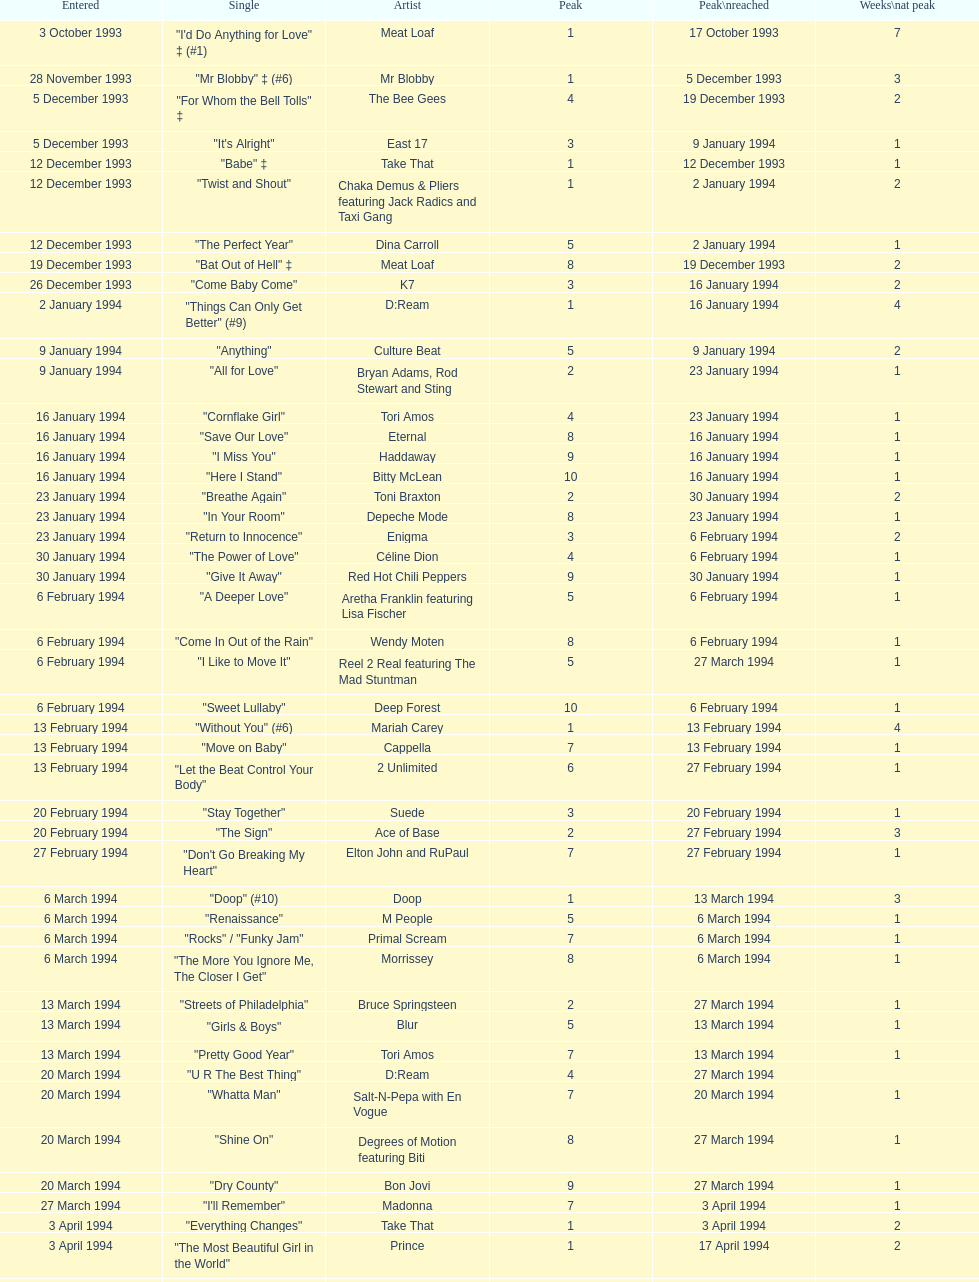This song released by celine dion spent 17 weeks on the uk singles chart in 1994, which one was it? "Think Twice". 